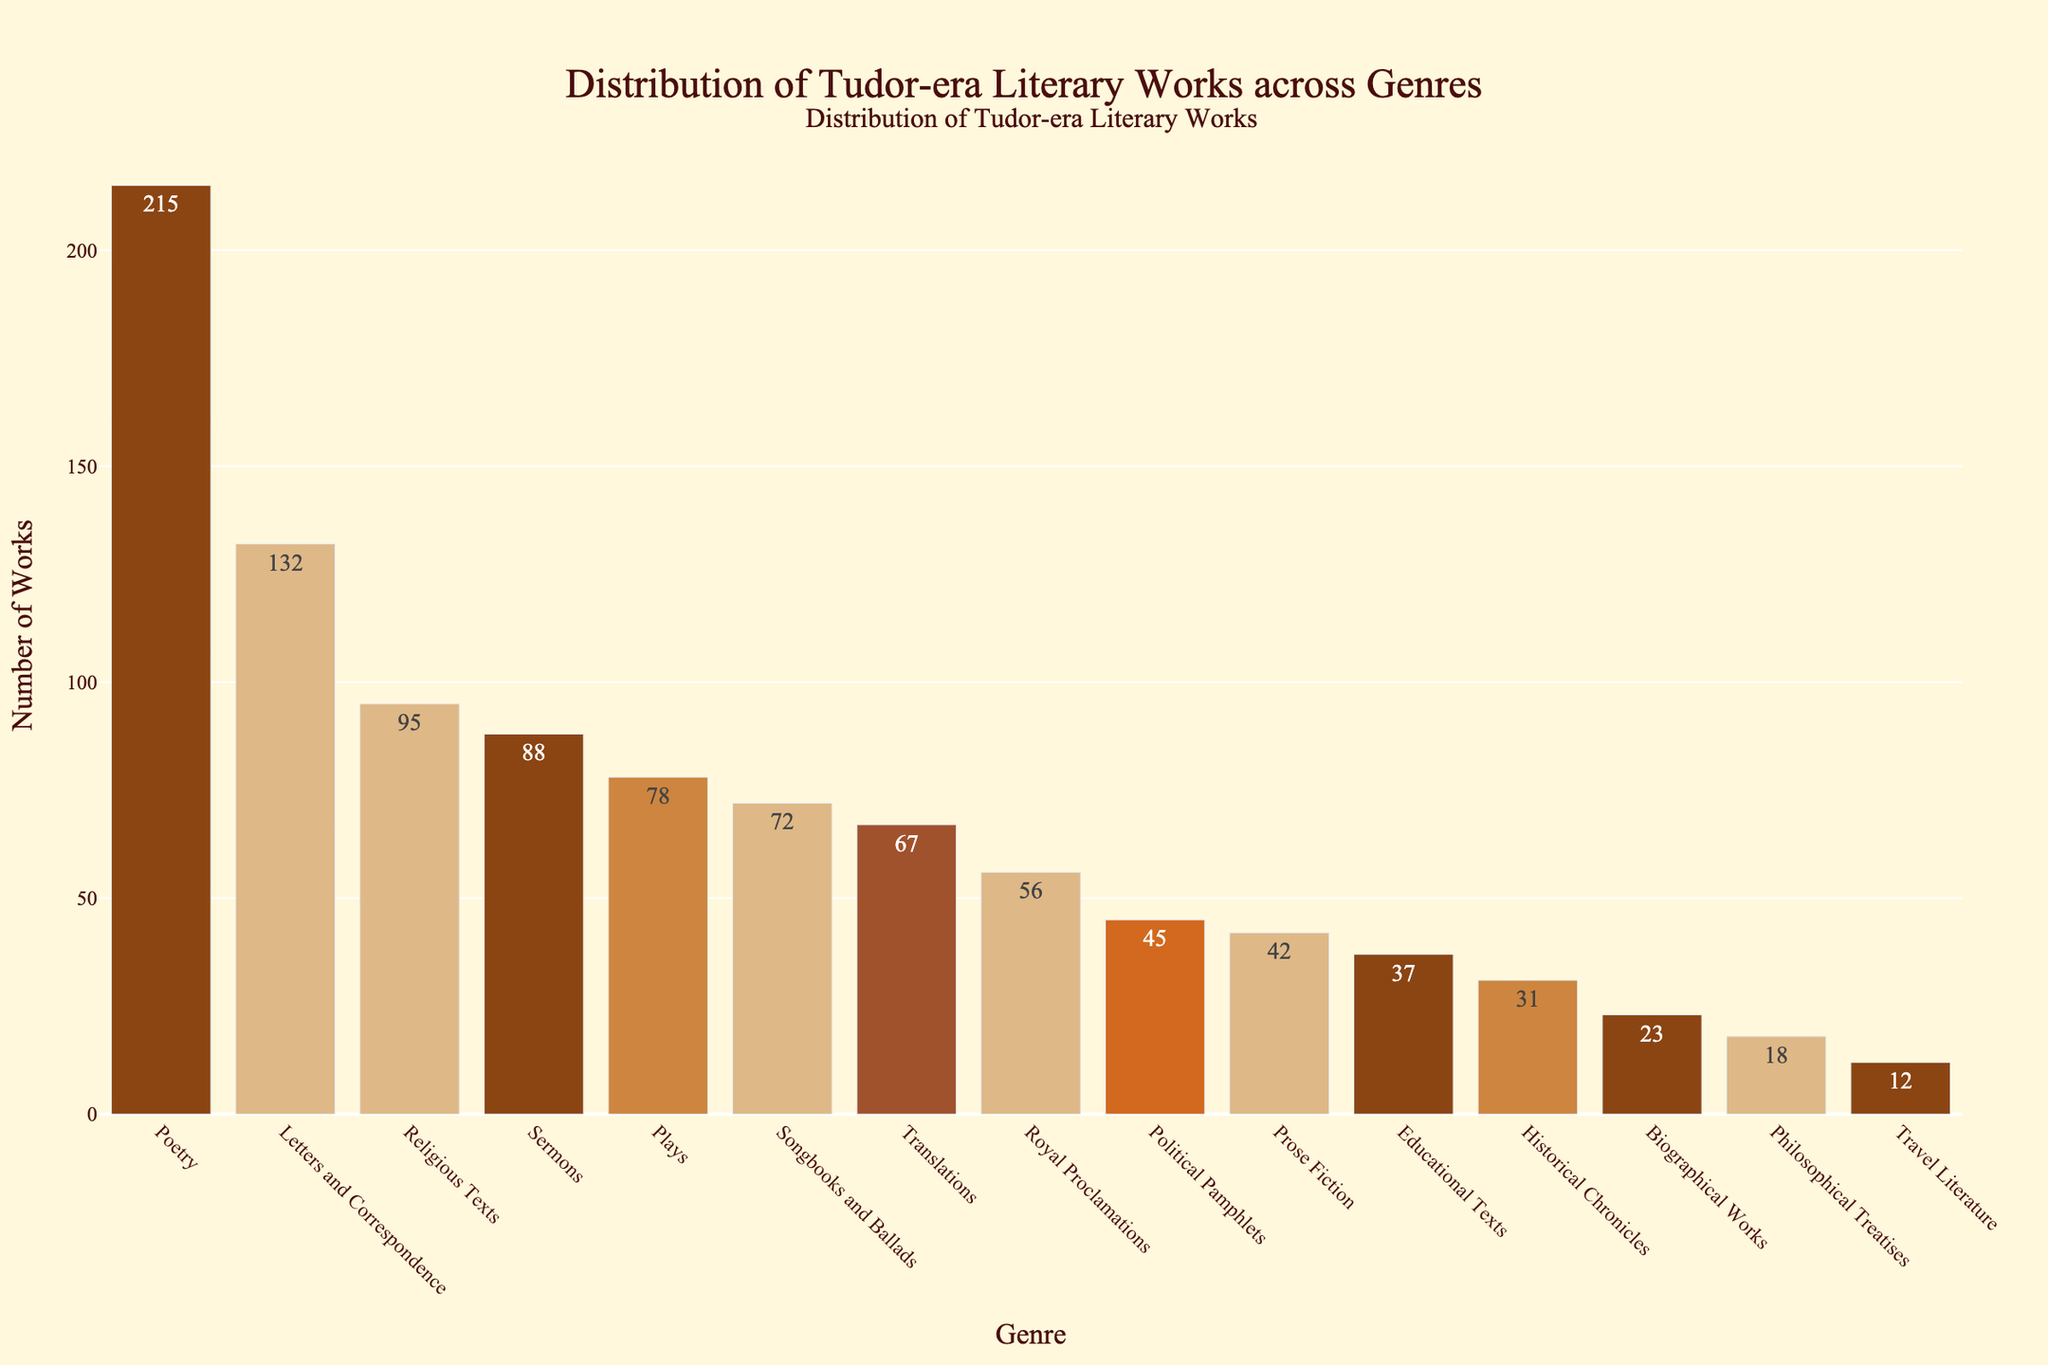Which genre has the highest number of works? The figure shows that the genre with the highest bar represents "Poetry." The number of works for this genre is 215.
Answer: Poetry Which genres have fewer works than "Religious Texts"? The figure indicates that "Religious Texts" have 95 works. Genres with fewer works are Plays, Prose Fiction, Historical Chronicles, Biographical Works, Philosophical Treatises, Travel Literature, Royal Proclamations, Translations, Sermons, Educational Texts, and Political Pamphlets.
Answer: Plays, Prose Fiction, Historical Chronicles, Biographical Works, Philosophical Treatises, Travel Literature, Royal Proclamations, Translations, Sermons, Educational Texts, Political Pamphlets How many more works does "Letters and Correspondence" have compared to "Plays"? "Letters and Correspondence" has 132 works and "Plays" has 78 works. The difference is 132 - 78.
Answer: 54 What is the total number of works for "Poetry", "Plays", and "Prose Fiction"? Sum the numbers for "Poetry" (215), "Plays" (78), and "Prose Fiction" (42). The total is 215 + 78 + 42.
Answer: 335 Which genre has the closest number of works to 100? The figure shows "Religious Texts" with 95 works and "Sermons" with 88 works. 95 is closer to 100 than 88.
Answer: Religious Texts What is the combined total of the five genres with the least number of works? The five genres with the least number of works are Travel Literature (12), Philosophical Treatises (18), Biographical Works (23), Historical Chronicles (31), and Educational Texts (37). Their combined total is 12 + 18 + 23 + 31 + 37.
Answer: 121 How does the number of works for "Sermons" compare to "Political Pamphlets"? "Sermons" has 88 works, while "Political Pamphlets" has 45 works. "Sermons" has more works than "Political Pamphlets".
Answer: Sermons have more What is the average number of works per genre if there are 15 genres in total? Summing all works: 215 + 78 + 42 + 31 + 95 + 23 + 18 + 12 + 56 + 132 + 67 + 88 + 37 + 45 + 72 = 1011. Average is 1011/15.
Answer: 67.4 